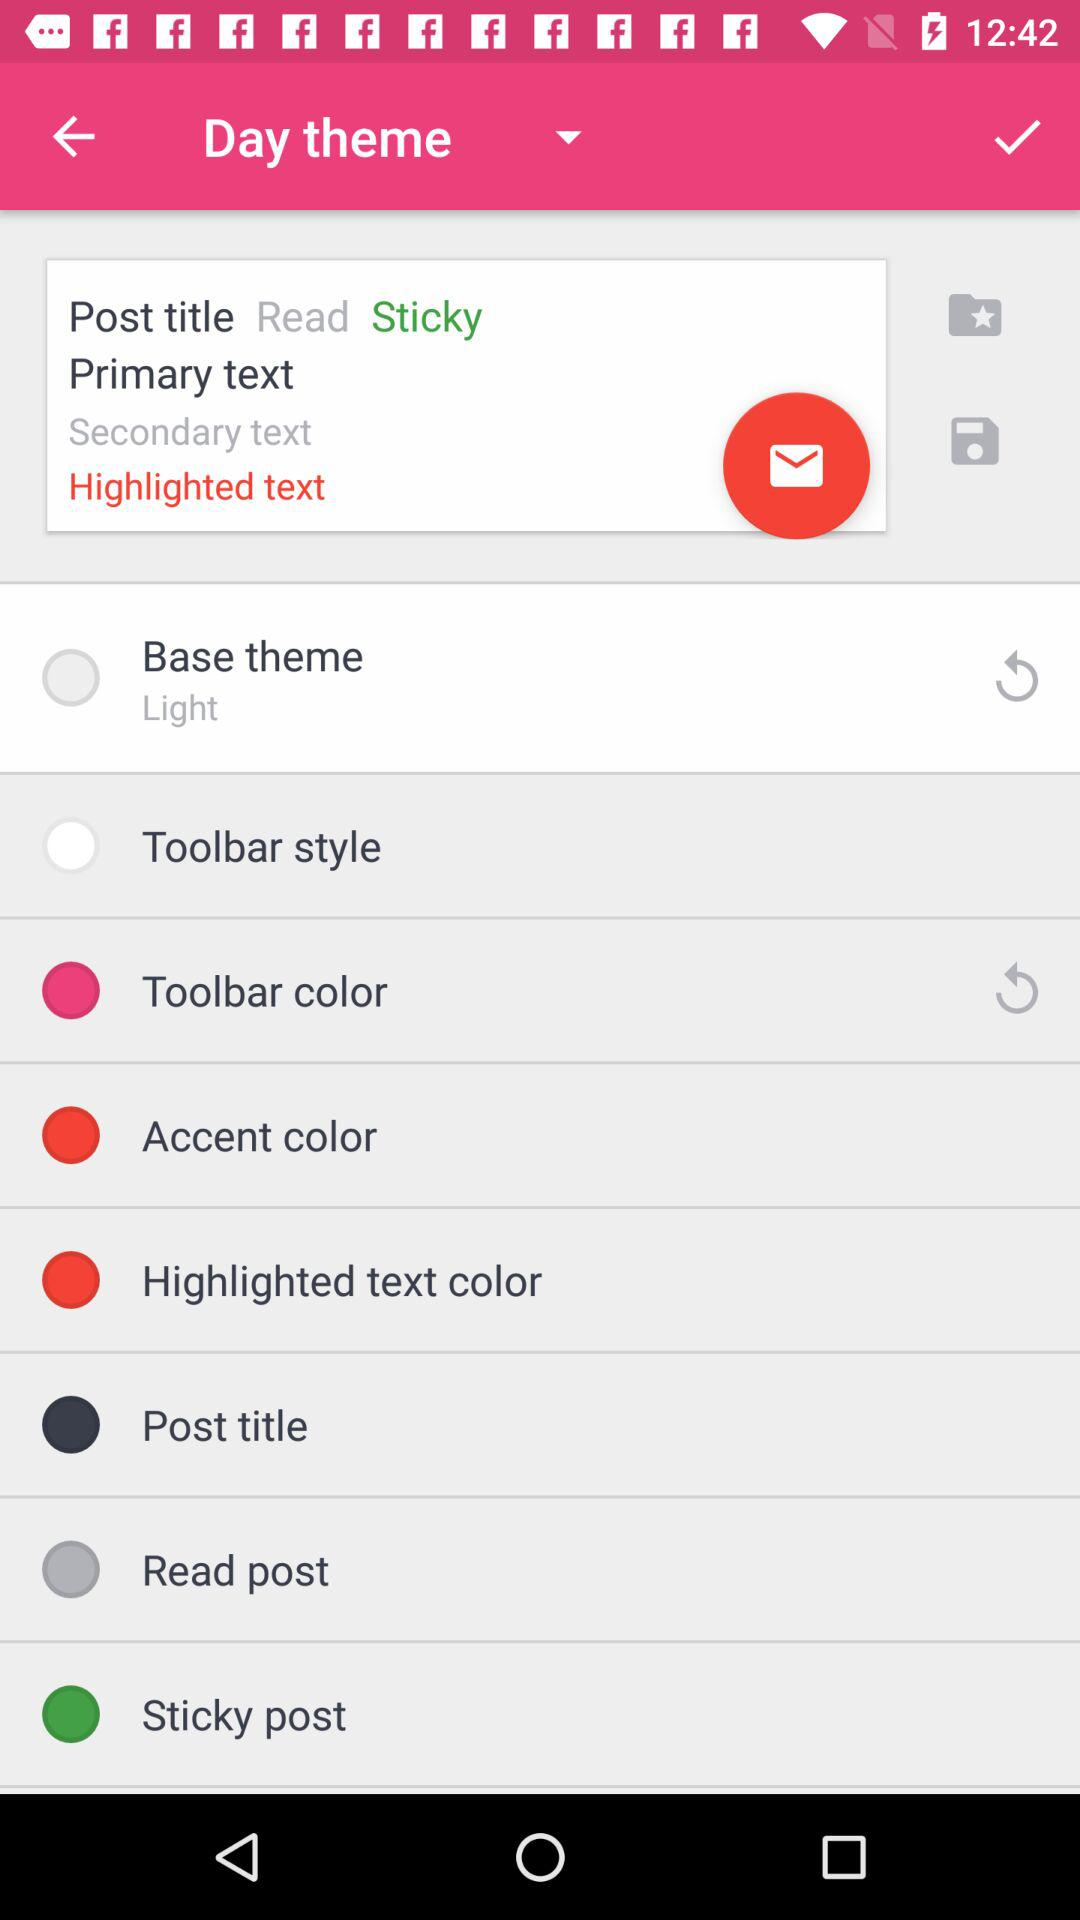What is the selected theme on the screen? The selected theme is "Base theme". 